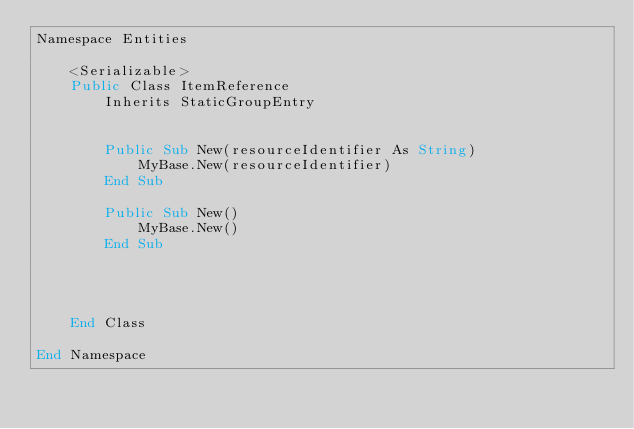Convert code to text. <code><loc_0><loc_0><loc_500><loc_500><_VisualBasic_>Namespace Entities

    <Serializable>
    Public Class ItemReference
        Inherits StaticGroupEntry


        Public Sub New(resourceIdentifier As String)
            MyBase.New(resourceIdentifier)
        End Sub

        Public Sub New()
            MyBase.New()
        End Sub




    End Class

End Namespace

</code> 